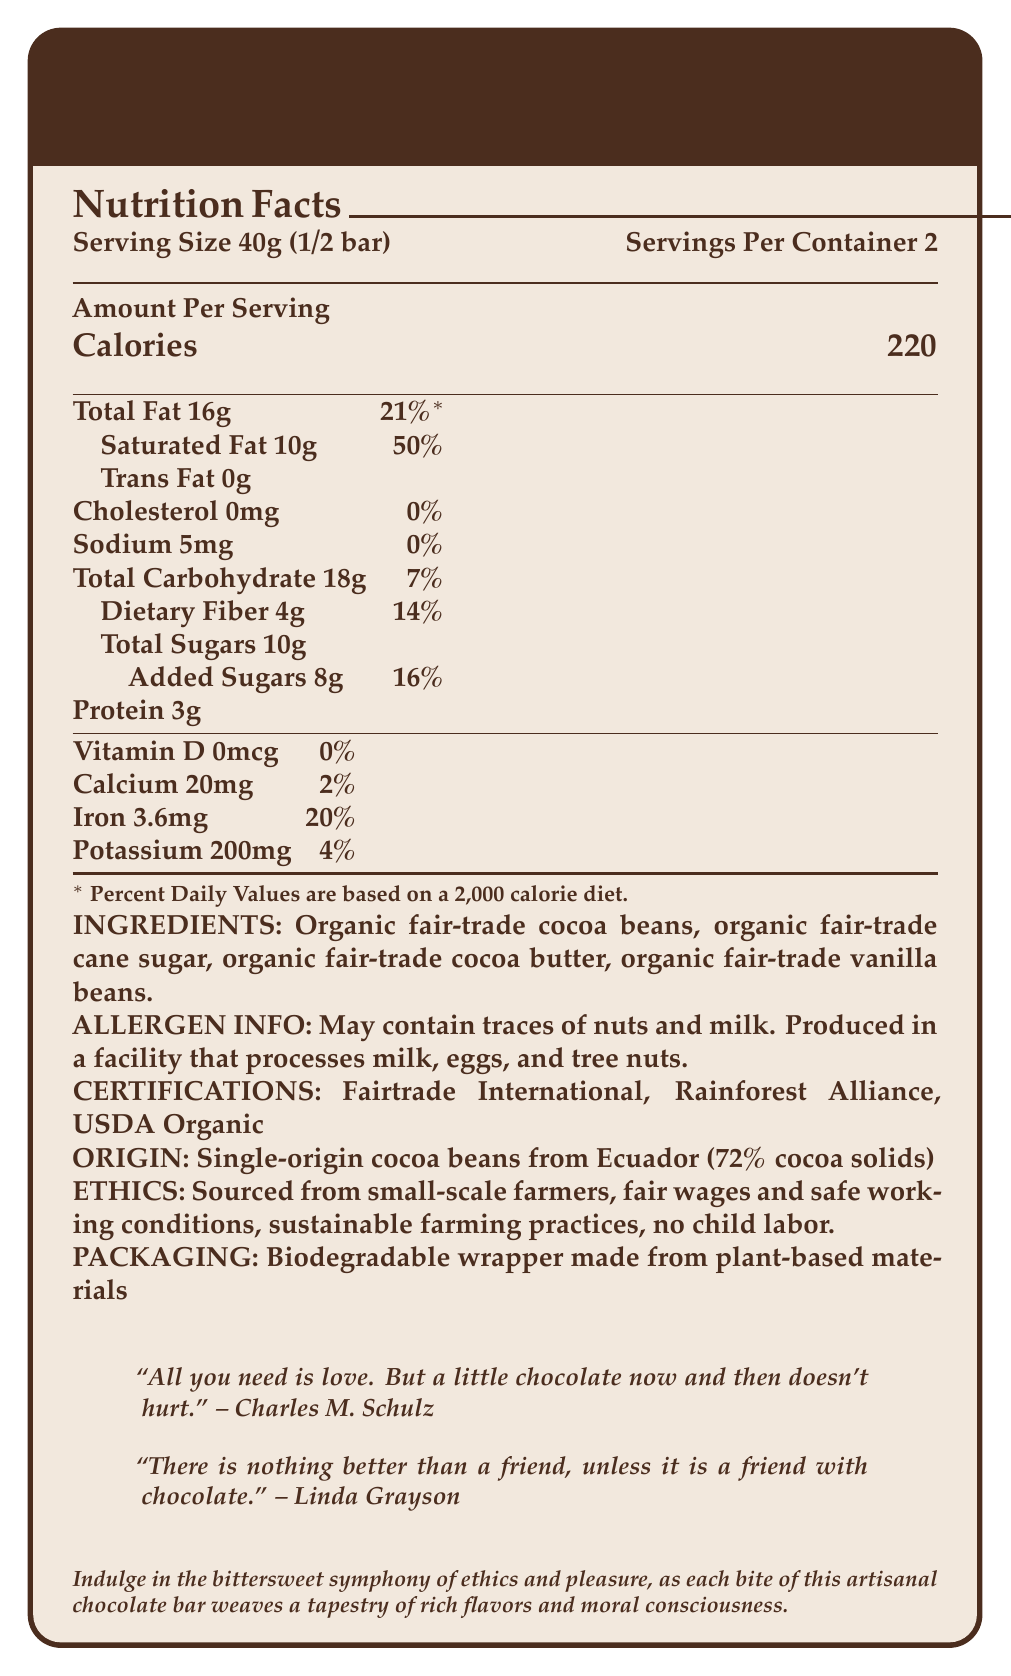What is the serving size for the Ethical Indulgence Dark Chocolate Bar? The document states that the serving size is 40g, which is half a bar.
Answer: 40g (1/2 bar) How many calories are in one serving of the chocolate bar? The document specifies that each serving contains 220 calories.
Answer: 220 calories What are the total fat and saturated fat contents per serving? The document lists the total fat as 16g and the saturated fat as 10g per serving.
Answer: Total fat: 16g, Saturated fat: 10g What is the origin of the cocoa beans used in this chocolate bar? The document states that the origin of the cocoa beans is Ecuador.
Answer: Single-origin cocoa beans from Ecuador Name one poetic quote about indulgence featured on the chocolate bar wrapper. The quote by Charles M. Schulz is one of the literary quotes featured.
Answer: "All you need is love. But a little chocolate now and then doesn't hurt." -- Charles M. Schulz How much dietary fiber is in each serving of the chocolate bar? The document mentions that there are 4g of dietary fiber per serving.
Answer: 4g What is the percentage daily value of iron per serving? The document indicates that the iron per serving amounts to 20% of the daily value.
Answer: 20% Identify one ethical certification that this chocolate bar holds. Among the ethical certifications listed is Fairtrade International.
Answer: Fairtrade International Which ingredient is used for sweetening the chocolate? The document lists organic fair-trade cane sugar as one of the ingredients.
Answer: Organic fair-trade cane sugar How many grams of added sugars are in each serving? The document states that each serving contains 8g of added sugars.
Answer: 8g How many servings are there per container? A. 1 B. 2 C. 3 D. 4 The document indicates that there are 2 servings per container.
Answer: B. 2 What is the main ethical aspect mentioned in the document regarding labor conditions? A. Limiting work hours B. No child labor C. Free housing D. Paid education for workers The document specifically mentions no child labor as part of its ethical production.
Answer: B. No child labor Which of the following is not an ingredient in the chocolate bar? A. Organic fair-trade vanilla beans B. Organic fair-trade cocoa beans C. Soy lecithin D. Organic fair-trade cocoa butter The document does not list soy lecithin as an ingredient.
Answer: C. Soy lecithin Does this chocolate bar contain any trans fat? The document clearly states that the chocolate bar contains 0g of trans fat.
Answer: No Summarize the main idea of the Ethical Indulgence Dark Chocolate Bar document. The main idea focuses on providing both nutritional insights and ethical considerations, reinforced with literary elements to enhance the appeal and context of the chocolate bar.
Answer: The document provides detailed nutritional information, ethical certifications, ingredient list, and literary quotes for a fair-trade, ethically-produced dark chocolate bar. The bar is made from organic, single-origin cocoa beans from Ecuador and emphasizes sustainable and ethical practices, including fair wages and no child labor. Suggested indulgence is highlighted through literary quotes and a poetic description. Explain how this chocolate bar aligns with ethical production standards. The ethical alignment is described in the sections about ethical certifications, origin, sourcing practices, and production ethics.
Answer: The chocolate bar is made from single-origin cocoa beans from Ecuador, sourced from small-scale farmers. The document mentions fair wages, safe working conditions, sustainable farming practices, and the prohibition of child labor. 